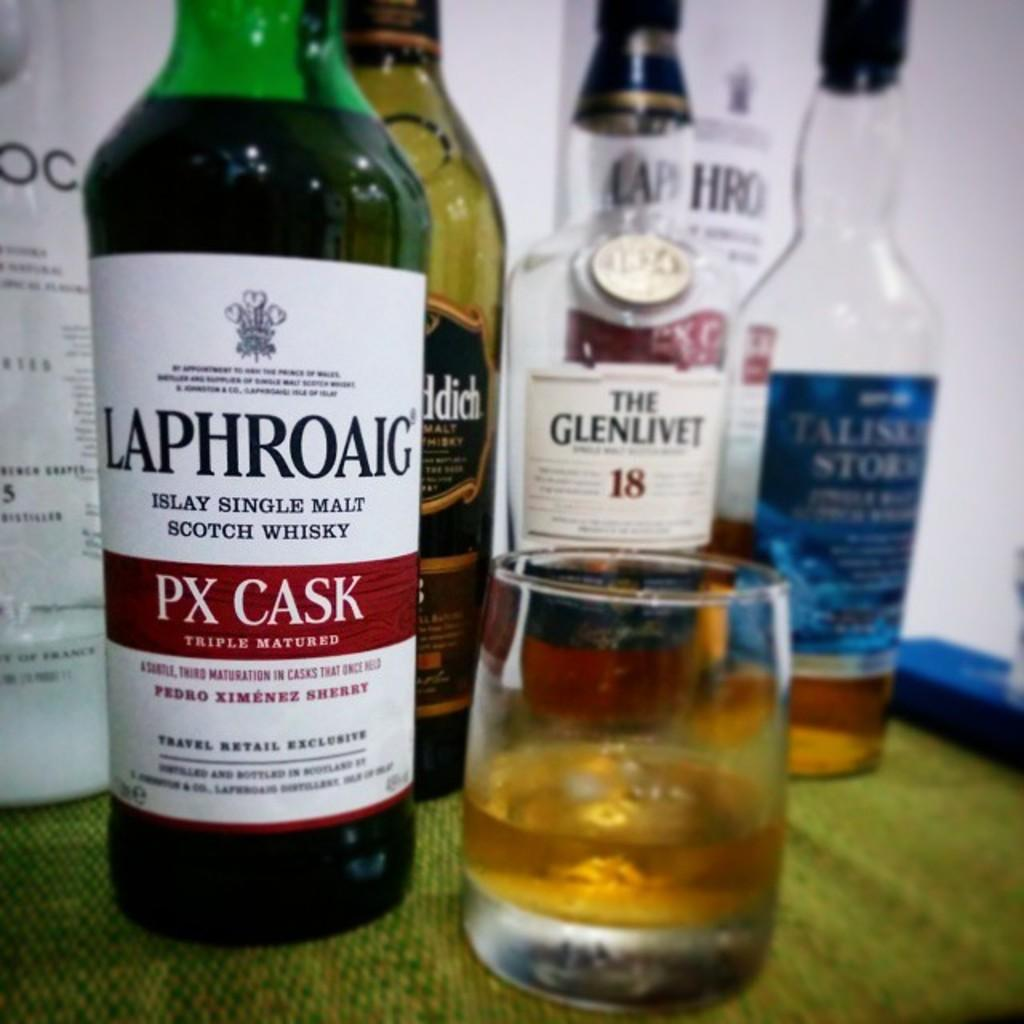<image>
Present a compact description of the photo's key features. bottle of px cask scotch whisky, the glenlivet 18, and others along with a partially filled glass 